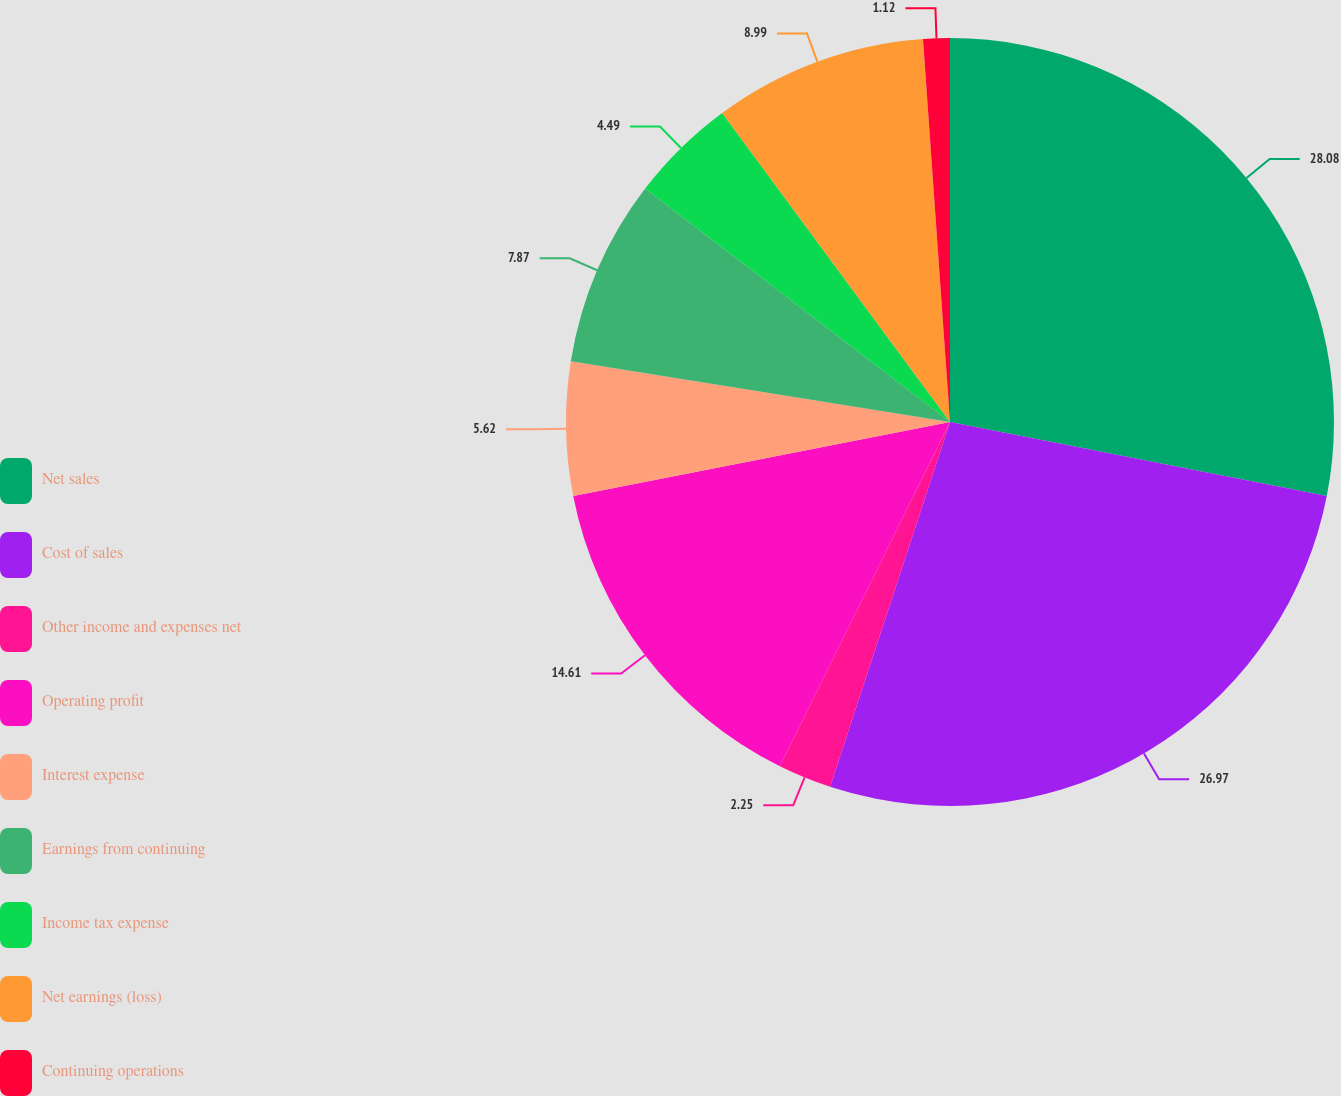Convert chart. <chart><loc_0><loc_0><loc_500><loc_500><pie_chart><fcel>Net sales<fcel>Cost of sales<fcel>Other income and expenses net<fcel>Operating profit<fcel>Interest expense<fcel>Earnings from continuing<fcel>Income tax expense<fcel>Net earnings (loss)<fcel>Continuing operations<nl><fcel>28.09%<fcel>26.97%<fcel>2.25%<fcel>14.61%<fcel>5.62%<fcel>7.87%<fcel>4.49%<fcel>8.99%<fcel>1.12%<nl></chart> 